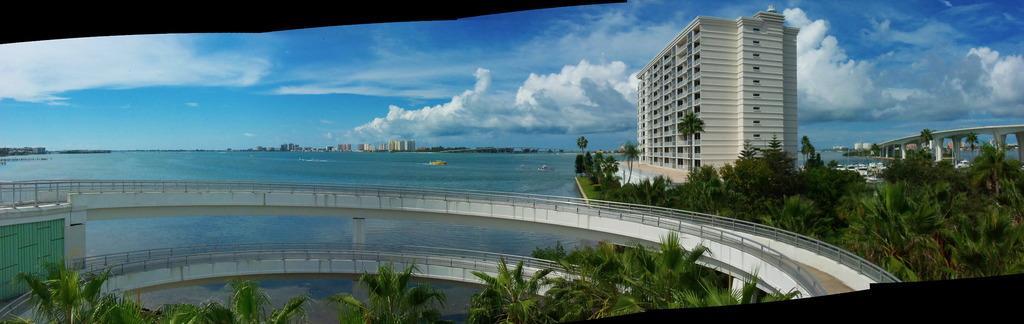Please provide a concise description of this image. In this picture we can see bridges, trees, here we can see boats on water and in the background we can see buildings and sky with clouds. 